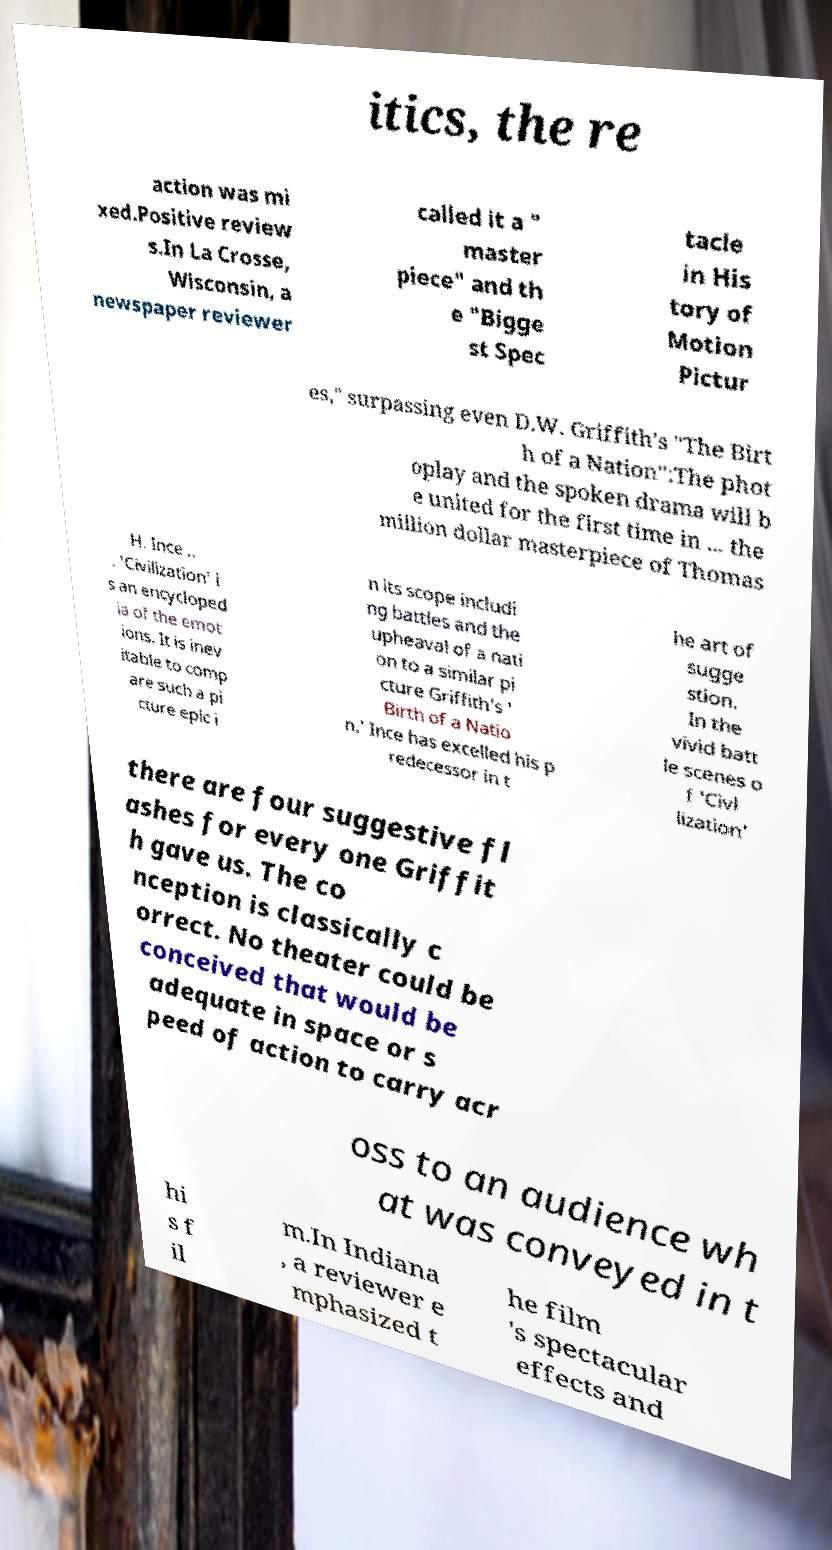Can you accurately transcribe the text from the provided image for me? itics, the re action was mi xed.Positive review s.In La Crosse, Wisconsin, a newspaper reviewer called it a " master piece" and th e "Bigge st Spec tacle in His tory of Motion Pictur es," surpassing even D.W. Griffith's "The Birt h of a Nation":The phot oplay and the spoken drama will b e united for the first time in ... the million dollar masterpiece of Thomas H. Ince .. . 'Civilization' i s an encycloped ia of the emot ions. It is inev itable to comp are such a pi cture epic i n its scope includi ng battles and the upheaval of a nati on to a similar pi cture Griffith's ' Birth of a Natio n.' Ince has excelled his p redecessor in t he art of sugge stion. In the vivid batt le scenes o f 'Civl lization' there are four suggestive fl ashes for every one Griffit h gave us. The co nception is classically c orrect. No theater could be conceived that would be adequate in space or s peed of action to carry acr oss to an audience wh at was conveyed in t hi s f il m.In Indiana , a reviewer e mphasized t he film 's spectacular effects and 